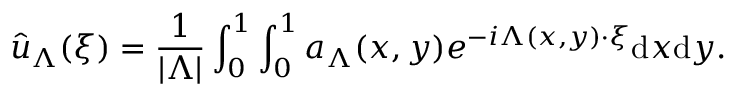<formula> <loc_0><loc_0><loc_500><loc_500>\hat { u } _ { \Lambda } ( \xi ) = \frac { 1 } { | \Lambda | } \int _ { 0 } ^ { 1 } \int _ { 0 } ^ { 1 } a _ { \Lambda } ( x , y ) e ^ { - i \Lambda ( x , y ) \cdot \xi } d x d y .</formula> 